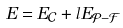<formula> <loc_0><loc_0><loc_500><loc_500>E = E _ { \mathcal { C } } + l E _ { \mathcal { P - F } }</formula> 